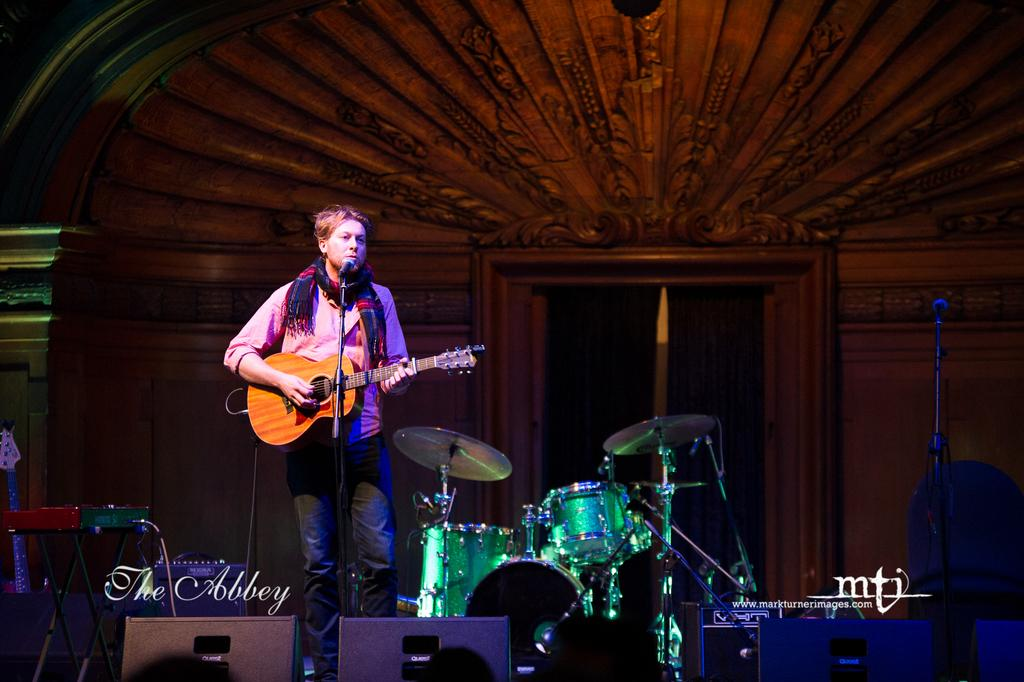What is the person in the image doing? The person is standing in front of a mic and holding a guitar. What other musical instrument is visible in the image? There is a drum set beside the person. What might the person be about to do? The person might be about to perform music, given the presence of a mic and musical instruments. How many babies are crawling on the floor in the image? There are no babies present in the image. What type of flesh can be seen on the person's hands in the image? There is no visible flesh on the person's hands in the image, as they are holding a guitar. 